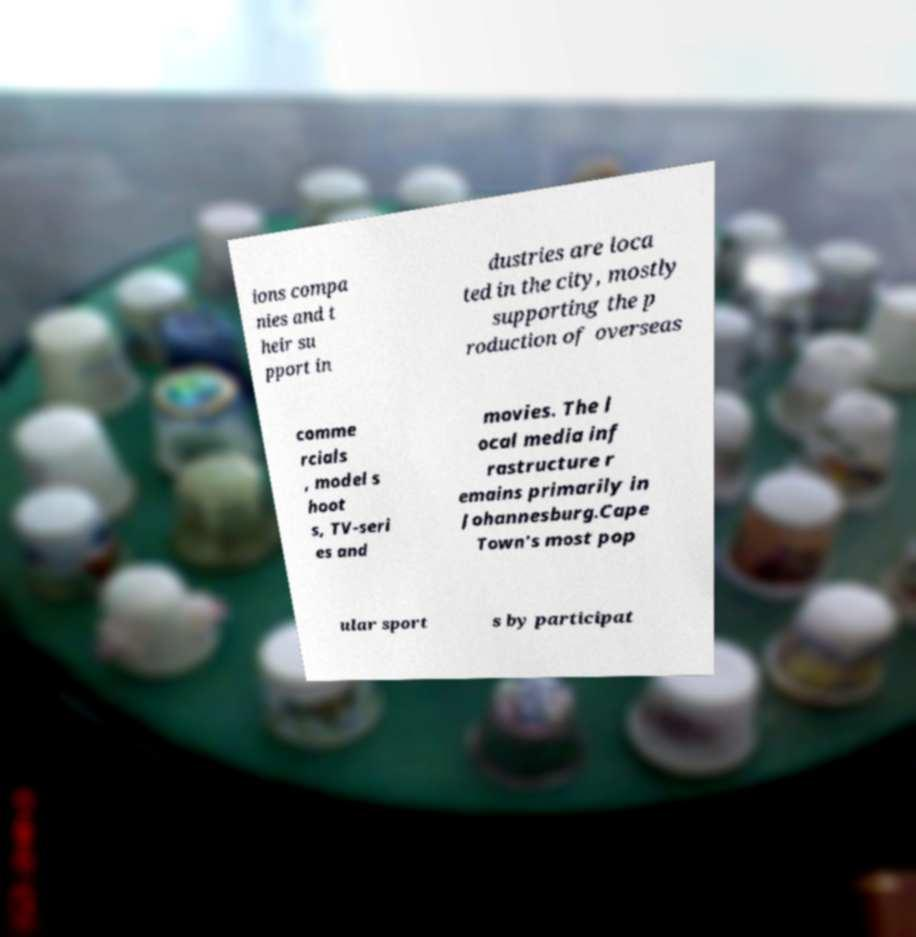Can you read and provide the text displayed in the image?This photo seems to have some interesting text. Can you extract and type it out for me? ions compa nies and t heir su pport in dustries are loca ted in the city, mostly supporting the p roduction of overseas comme rcials , model s hoot s, TV-seri es and movies. The l ocal media inf rastructure r emains primarily in Johannesburg.Cape Town's most pop ular sport s by participat 